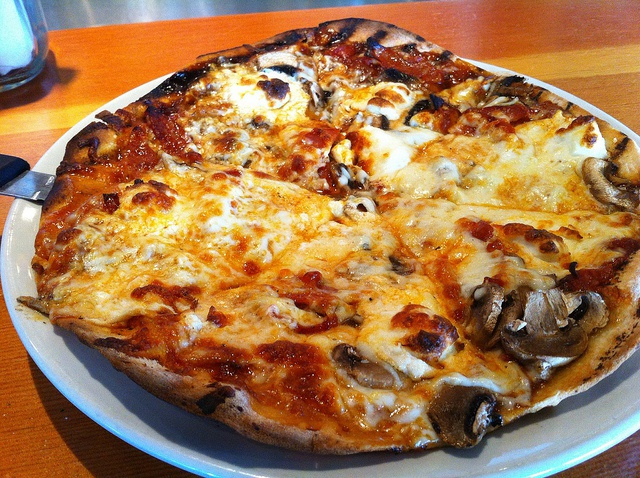Describe the objects in this image and their specific colors. I can see dining table in brown, maroon, orange, tan, and black tones, pizza in cyan, brown, maroon, orange, and tan tones, and knife in cyan, black, gray, and lightblue tones in this image. 